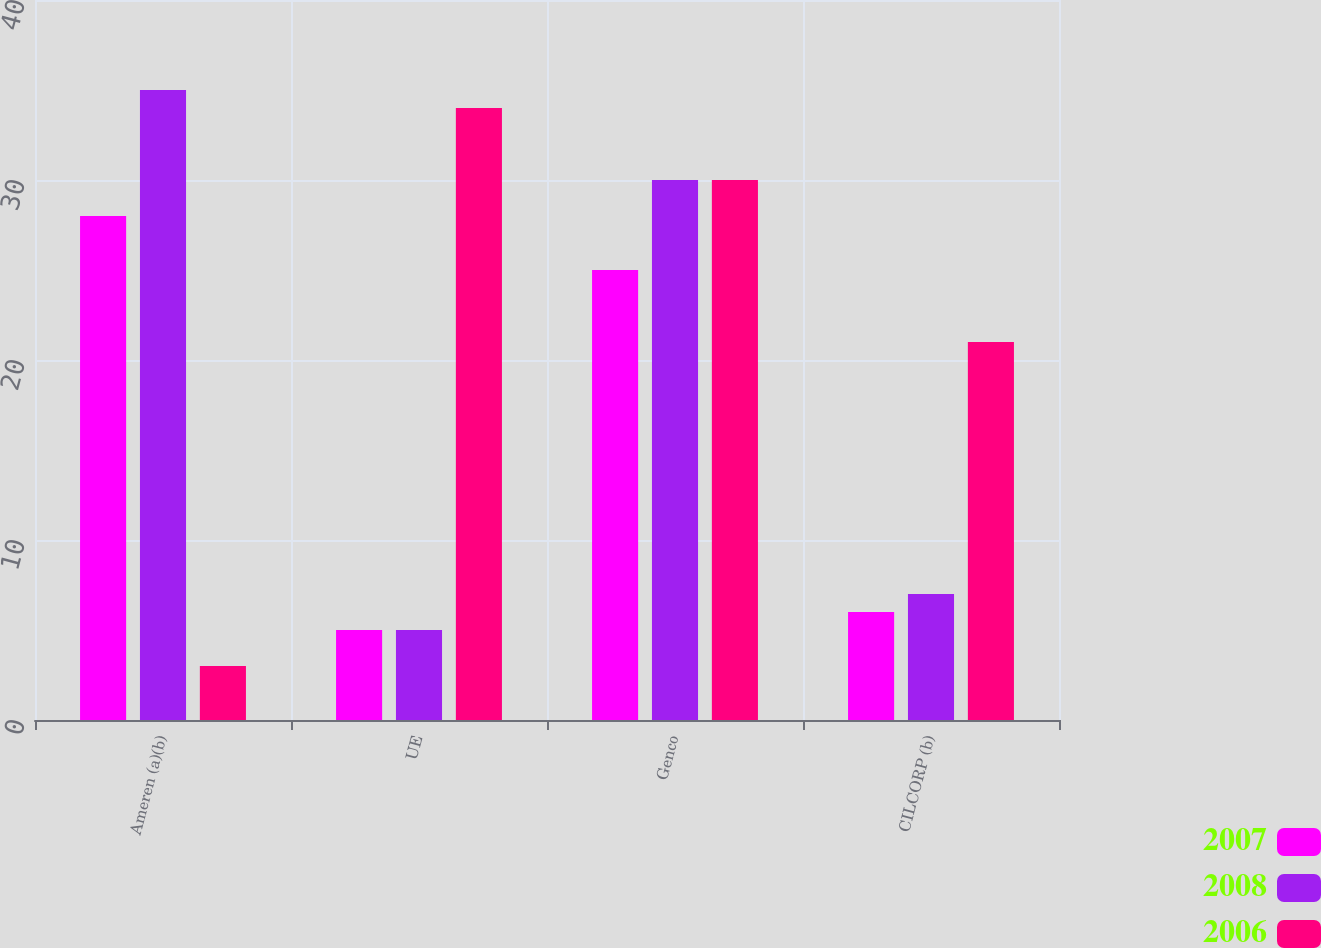Convert chart to OTSL. <chart><loc_0><loc_0><loc_500><loc_500><stacked_bar_chart><ecel><fcel>Ameren (a)(b)<fcel>UE<fcel>Genco<fcel>CILCORP (b)<nl><fcel>2007<fcel>28<fcel>5<fcel>25<fcel>6<nl><fcel>2008<fcel>35<fcel>5<fcel>30<fcel>7<nl><fcel>2006<fcel>3<fcel>34<fcel>30<fcel>21<nl></chart> 